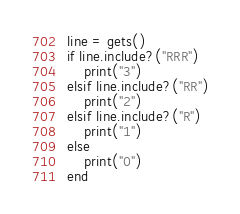<code> <loc_0><loc_0><loc_500><loc_500><_Ruby_>line = gets()
if line.include?("RRR")
    print("3")
elsif line.include?("RR")
    print("2")
elsif line.include?("R")
    print("1")
else
    print("0")
end</code> 